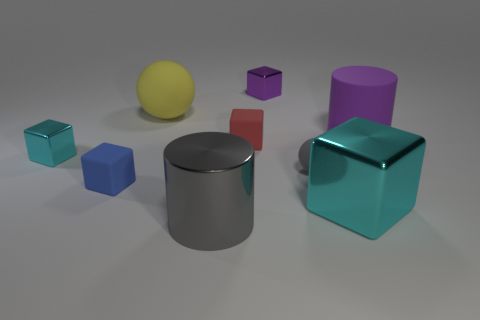Does the large purple cylinder have the same material as the cyan block to the left of the large yellow object?
Keep it short and to the point. No. Is the red matte object the same shape as the small blue thing?
Keep it short and to the point. Yes. There is a blue thing that is the same shape as the red matte thing; what material is it?
Provide a short and direct response. Rubber. The metallic block that is behind the gray rubber object and to the right of the yellow thing is what color?
Ensure brevity in your answer.  Purple. What is the color of the small ball?
Ensure brevity in your answer.  Gray. There is a small object that is the same color as the large block; what is it made of?
Offer a terse response. Metal. Is there another red rubber object that has the same shape as the small red matte object?
Your response must be concise. No. How big is the matte object that is behind the purple cylinder?
Provide a succinct answer. Large. What material is the cyan object that is the same size as the yellow ball?
Keep it short and to the point. Metal. Is the number of green rubber cylinders greater than the number of big cylinders?
Provide a short and direct response. No. 